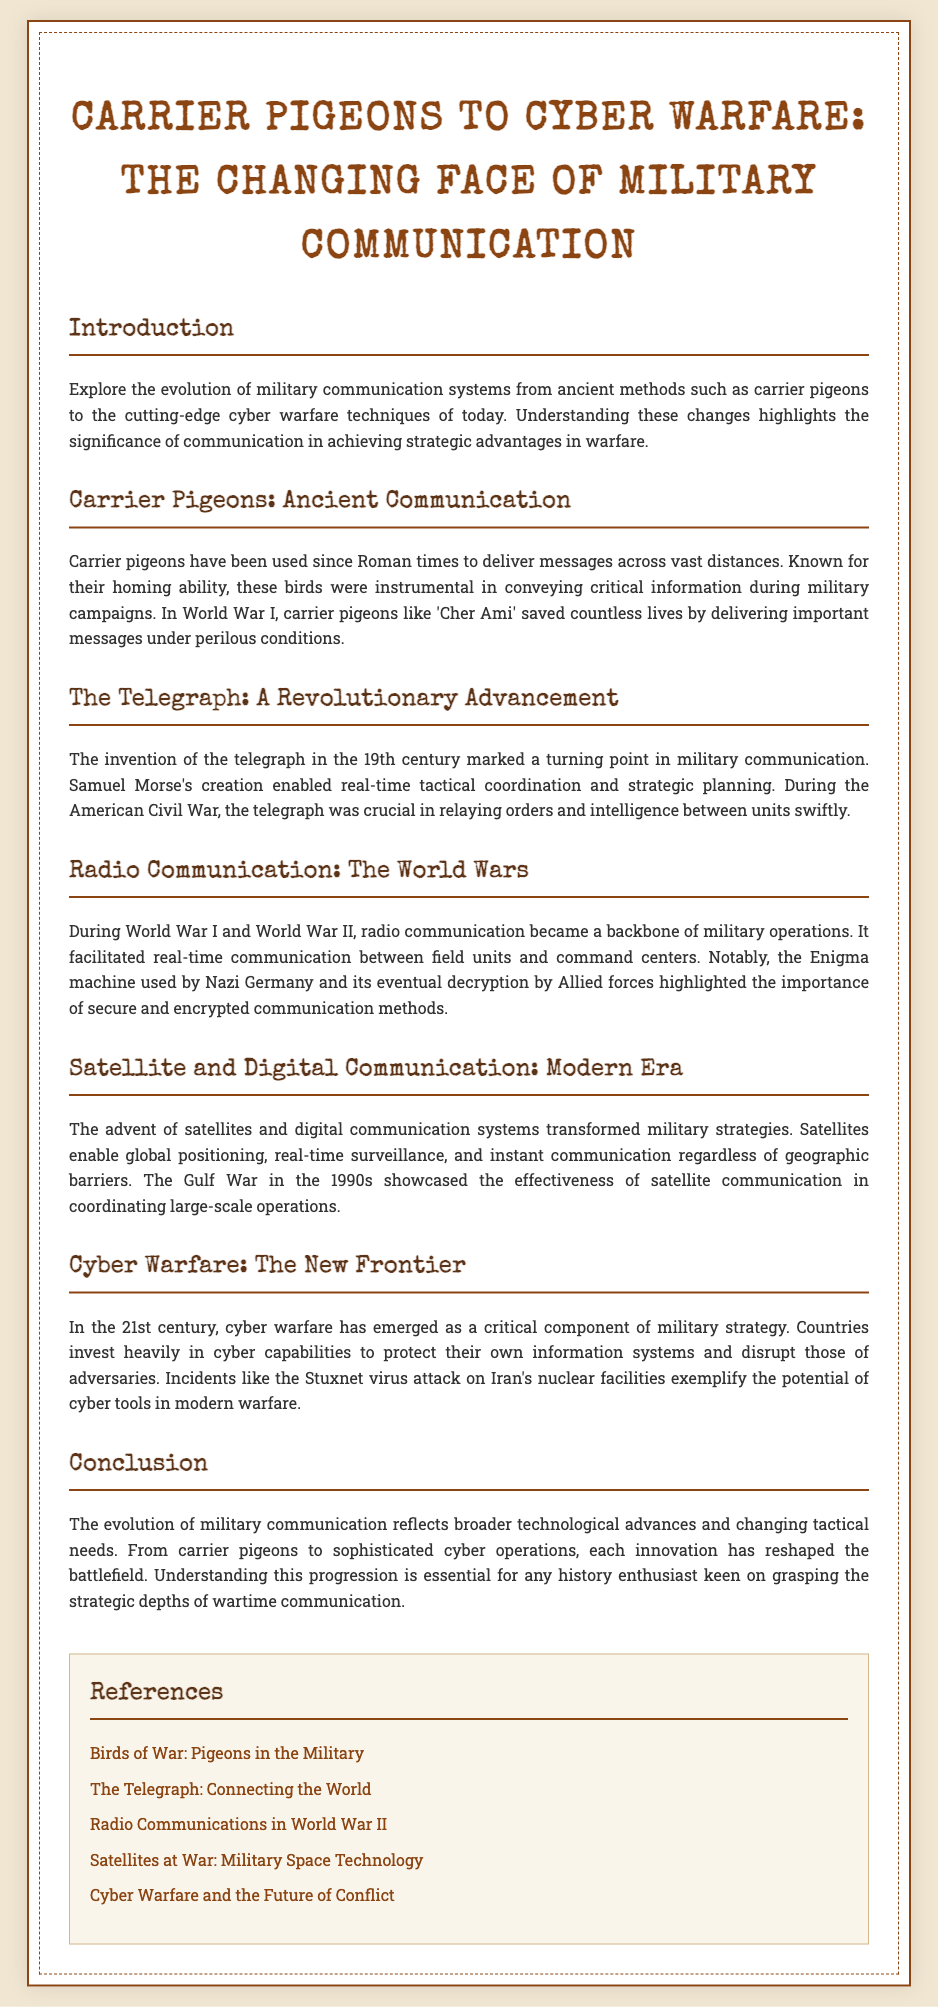What was the role of carrier pigeons in World War I? The document states that carrier pigeons like 'Cher Ami' saved countless lives by delivering important messages under perilous conditions during World War I.
Answer: 'Cher Ami' What invention marked a turning point in military communication? According to the document, the invention of the telegraph in the 19th century marked a turning point in military communication.
Answer: Telegraph What major conflict highlighted the importance of radio communication? The document indicates that both World War I and World War II highlighted the importance of radio communication.
Answer: World Wars What type of communication is described as transforming military strategies in the modern era? The document mentions that satellite and digital communication systems transformed military strategies.
Answer: Satellite and digital communication What event exemplifies the potential of cyber tools in modern warfare? The document cites the Stuxnet virus attack on Iran's nuclear facilities as an example of the potential of cyber tools in modern warfare.
Answer: Stuxnet virus attack Which bird was used to deliver messages historically? The document discusses the use of carrier pigeons since Roman times to deliver messages across vast distances.
Answer: Carrier pigeons What is the overarching theme of the document? The document explores the evolution of military communication systems from ancient methods to modern cyber warfare techniques.
Answer: Evolution of military communication How does the document conclude about military communication? The conclusion explains that understanding the progression of military communication is essential for grasping the strategic depths of wartime communication.
Answer: Essential understanding 